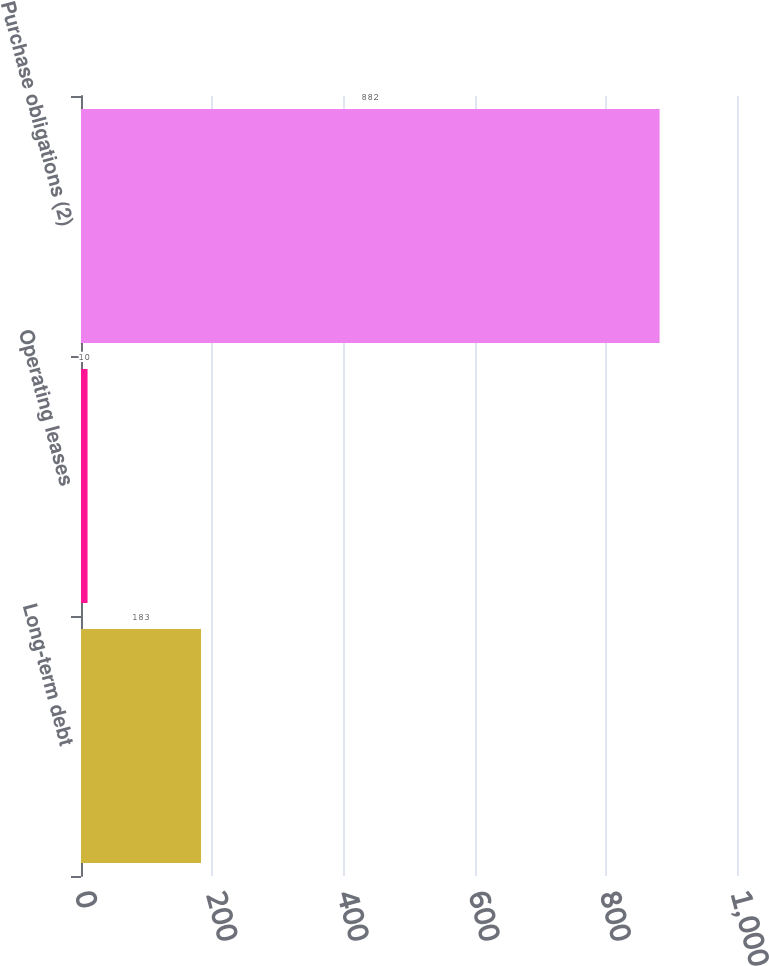Convert chart to OTSL. <chart><loc_0><loc_0><loc_500><loc_500><bar_chart><fcel>Long-term debt<fcel>Operating leases<fcel>Purchase obligations (2)<nl><fcel>183<fcel>10<fcel>882<nl></chart> 